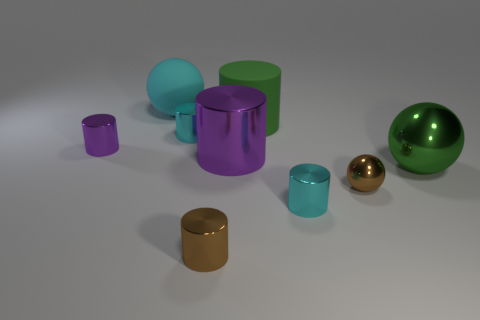What is the color of the large metallic cylinder?
Your answer should be very brief. Purple. What number of objects are rubber cylinders or large cylinders?
Provide a succinct answer. 2. There is a purple cylinder that is the same size as the brown metallic cylinder; what is it made of?
Offer a terse response. Metal. How big is the sphere that is behind the big metal ball?
Offer a terse response. Large. What is the material of the large green ball?
Your response must be concise. Metal. How many objects are small cyan shiny objects that are behind the small sphere or large things that are to the left of the tiny brown metal ball?
Give a very brief answer. 4. How many other objects are there of the same color as the matte cylinder?
Make the answer very short. 1. There is a big green matte object; is it the same shape as the small cyan shiny object that is behind the big purple cylinder?
Keep it short and to the point. Yes. Is the number of green balls that are on the left side of the large green rubber thing less than the number of balls that are left of the green sphere?
Your answer should be very brief. Yes. There is another tiny object that is the same shape as the green metallic thing; what is its material?
Your answer should be very brief. Metal. 